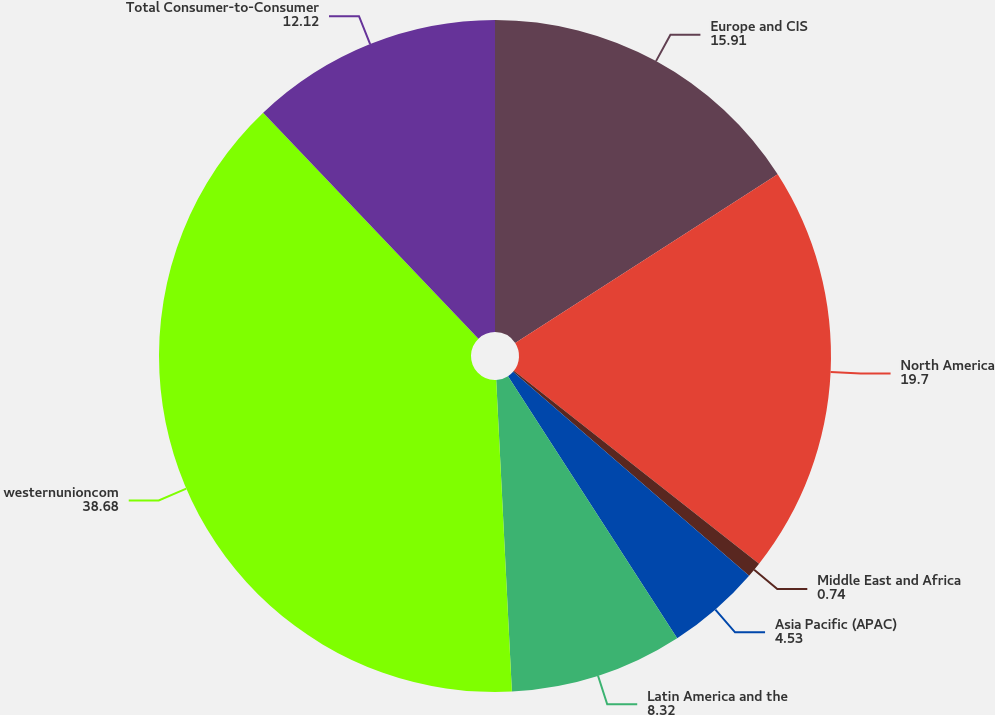Convert chart to OTSL. <chart><loc_0><loc_0><loc_500><loc_500><pie_chart><fcel>Europe and CIS<fcel>North America<fcel>Middle East and Africa<fcel>Asia Pacific (APAC)<fcel>Latin America and the<fcel>westernunioncom<fcel>Total Consumer-to-Consumer<nl><fcel>15.91%<fcel>19.7%<fcel>0.74%<fcel>4.53%<fcel>8.32%<fcel>38.68%<fcel>12.12%<nl></chart> 